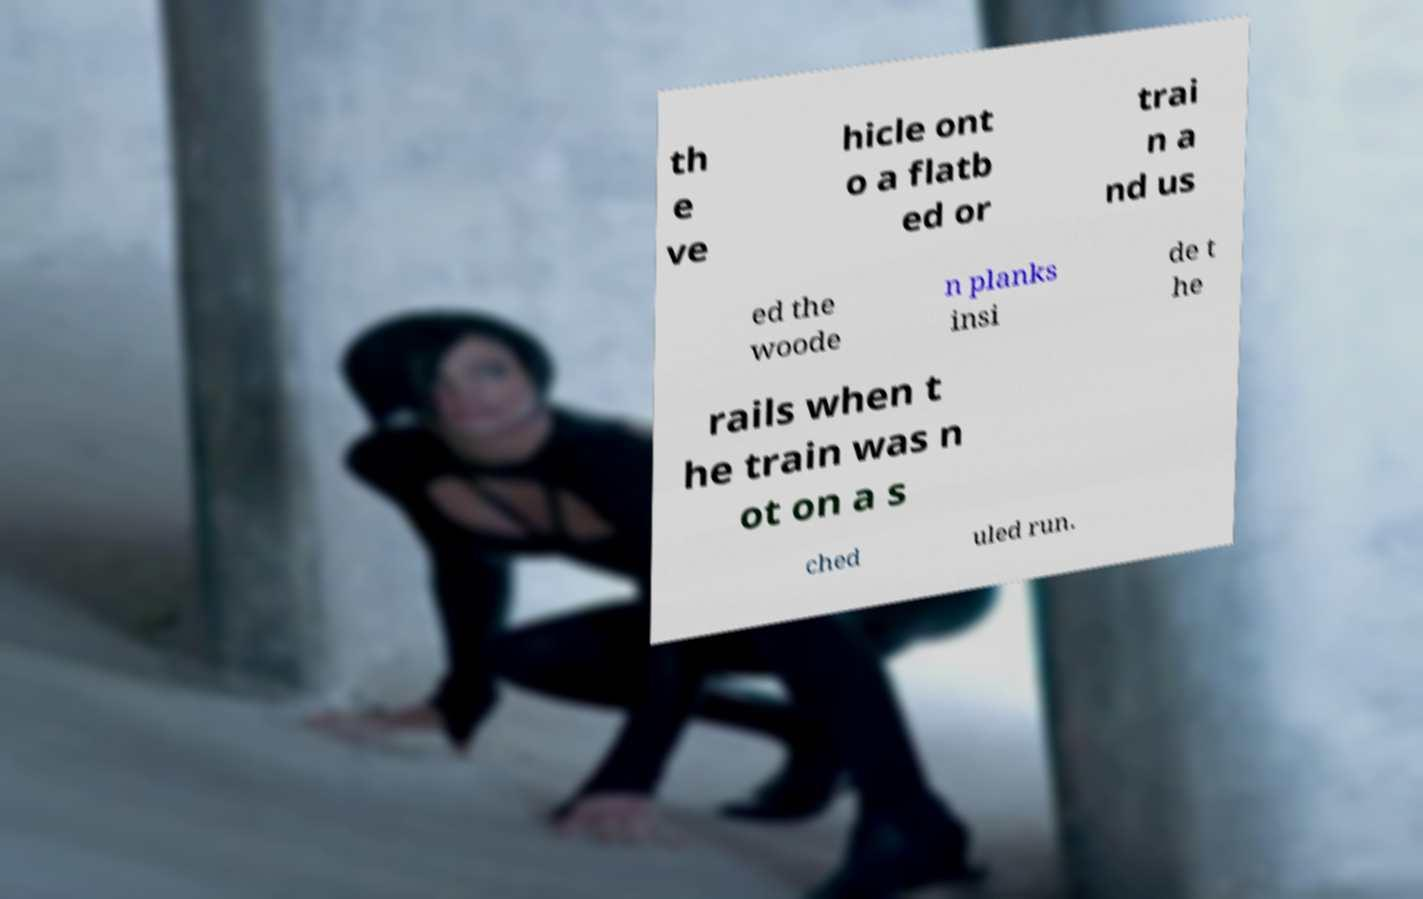I need the written content from this picture converted into text. Can you do that? th e ve hicle ont o a flatb ed or trai n a nd us ed the woode n planks insi de t he rails when t he train was n ot on a s ched uled run. 